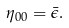<formula> <loc_0><loc_0><loc_500><loc_500>\eta _ { 0 0 } = \bar { \epsilon } .</formula> 